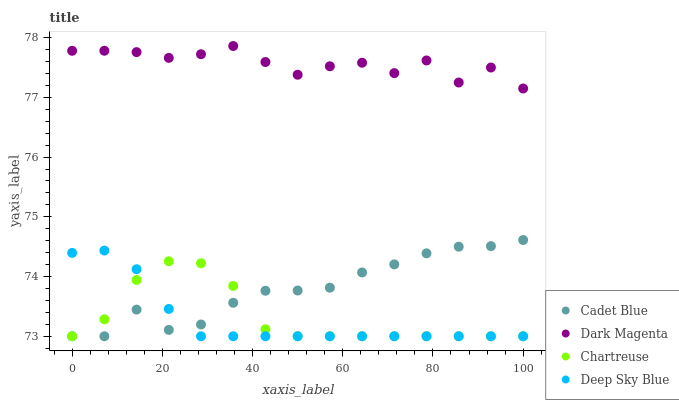Does Deep Sky Blue have the minimum area under the curve?
Answer yes or no. Yes. Does Dark Magenta have the maximum area under the curve?
Answer yes or no. Yes. Does Cadet Blue have the minimum area under the curve?
Answer yes or no. No. Does Cadet Blue have the maximum area under the curve?
Answer yes or no. No. Is Deep Sky Blue the smoothest?
Answer yes or no. Yes. Is Dark Magenta the roughest?
Answer yes or no. Yes. Is Cadet Blue the smoothest?
Answer yes or no. No. Is Cadet Blue the roughest?
Answer yes or no. No. Does Chartreuse have the lowest value?
Answer yes or no. Yes. Does Dark Magenta have the lowest value?
Answer yes or no. No. Does Dark Magenta have the highest value?
Answer yes or no. Yes. Does Cadet Blue have the highest value?
Answer yes or no. No. Is Chartreuse less than Dark Magenta?
Answer yes or no. Yes. Is Dark Magenta greater than Deep Sky Blue?
Answer yes or no. Yes. Does Deep Sky Blue intersect Cadet Blue?
Answer yes or no. Yes. Is Deep Sky Blue less than Cadet Blue?
Answer yes or no. No. Is Deep Sky Blue greater than Cadet Blue?
Answer yes or no. No. Does Chartreuse intersect Dark Magenta?
Answer yes or no. No. 